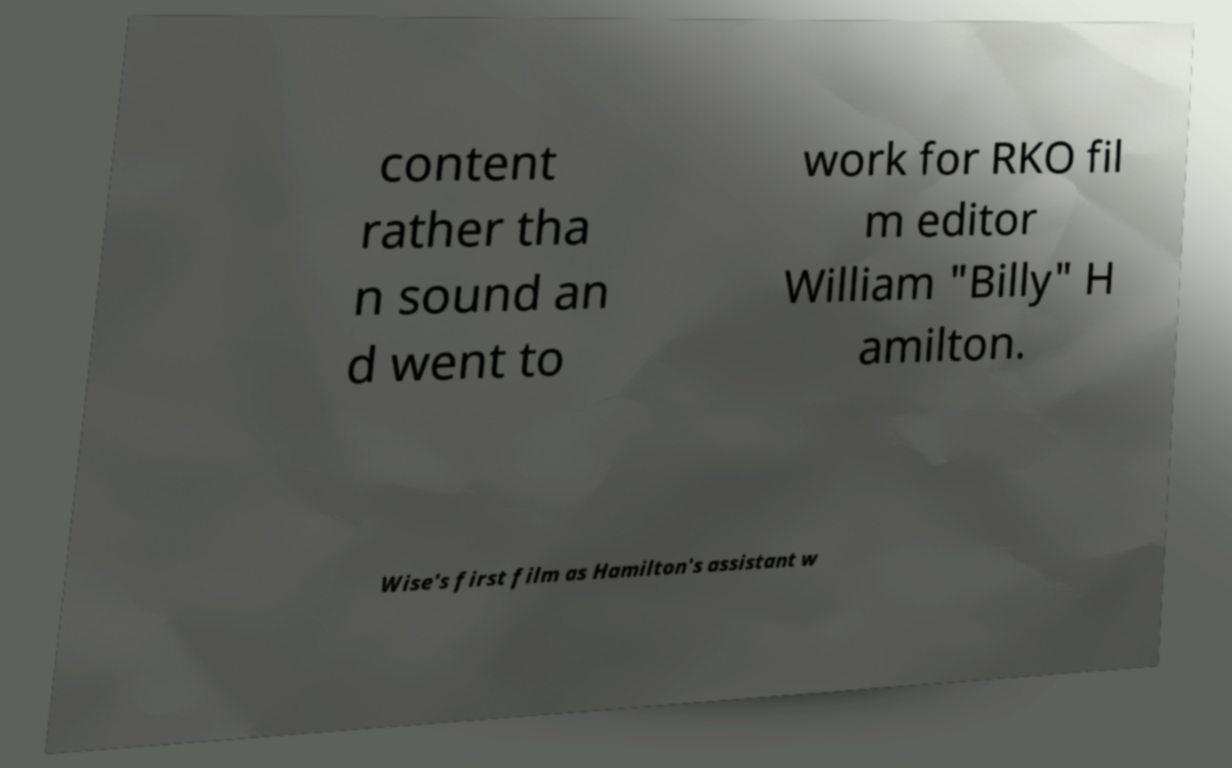Please identify and transcribe the text found in this image. content rather tha n sound an d went to work for RKO fil m editor William "Billy" H amilton. Wise's first film as Hamilton's assistant w 